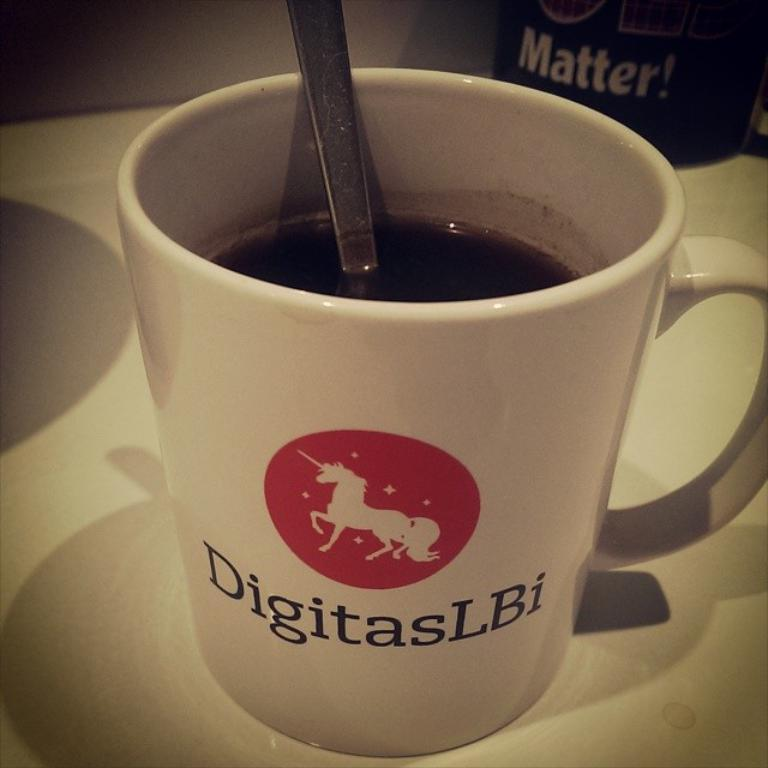<image>
Offer a succinct explanation of the picture presented. A coffee cup with a spoon in it that has a design by DigitasLBi on it with a unicorn. 